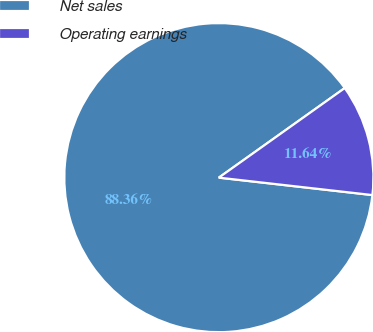Convert chart to OTSL. <chart><loc_0><loc_0><loc_500><loc_500><pie_chart><fcel>Net sales<fcel>Operating earnings<nl><fcel>88.36%<fcel>11.64%<nl></chart> 